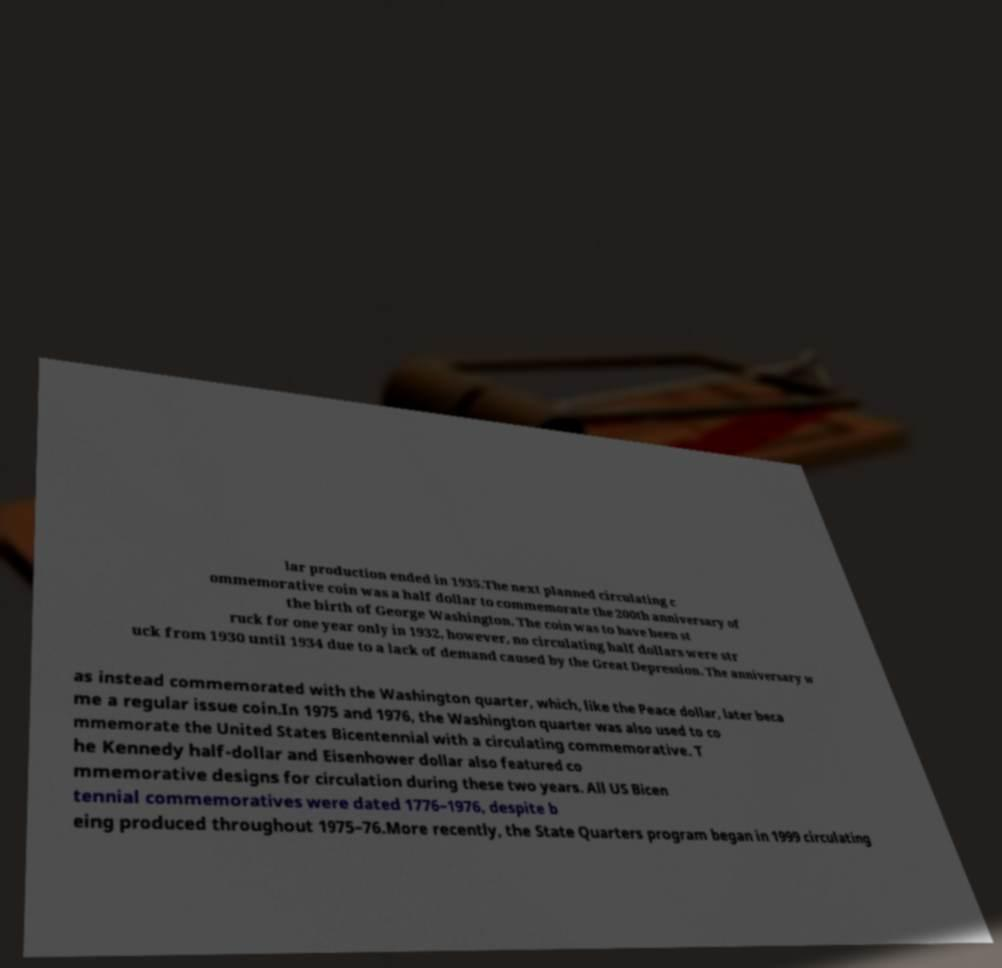There's text embedded in this image that I need extracted. Can you transcribe it verbatim? lar production ended in 1935.The next planned circulating c ommemorative coin was a half dollar to commemorate the 200th anniversary of the birth of George Washington. The coin was to have been st ruck for one year only in 1932, however, no circulating half dollars were str uck from 1930 until 1934 due to a lack of demand caused by the Great Depression. The anniversary w as instead commemorated with the Washington quarter, which, like the Peace dollar, later beca me a regular issue coin.In 1975 and 1976, the Washington quarter was also used to co mmemorate the United States Bicentennial with a circulating commemorative. T he Kennedy half-dollar and Eisenhower dollar also featured co mmemorative designs for circulation during these two years. All US Bicen tennial commemoratives were dated 1776–1976, despite b eing produced throughout 1975–76.More recently, the State Quarters program began in 1999 circulating 